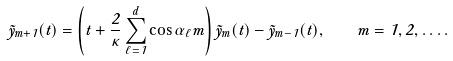<formula> <loc_0><loc_0><loc_500><loc_500>\tilde { y } _ { m + 1 } ( t ) = \left ( t + \frac { 2 } { \kappa } \sum _ { \ell = 1 } ^ { d } \cos \alpha _ { \ell } m \right ) \tilde { y } _ { m } ( t ) - \tilde { y } _ { m - 1 } ( t ) , \quad m = 1 , 2 , \dots .</formula> 